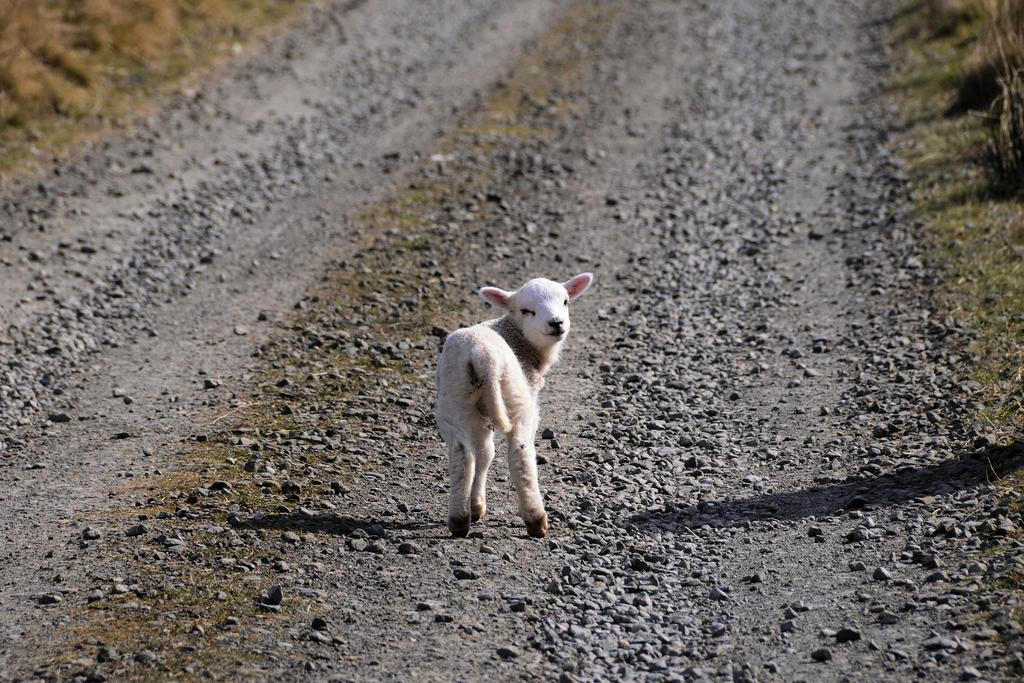What type of animal can be seen in the image? There is a white animal in the image. What is the animal standing on? The animal is standing on rocks. What direction is the animal facing? The animal is turning backwards. What type of vegetation is present around the rocks? There is grass around the rocks. What type of flowers can be seen growing on the animal in the image? There are no flowers present on the animal in the image. 